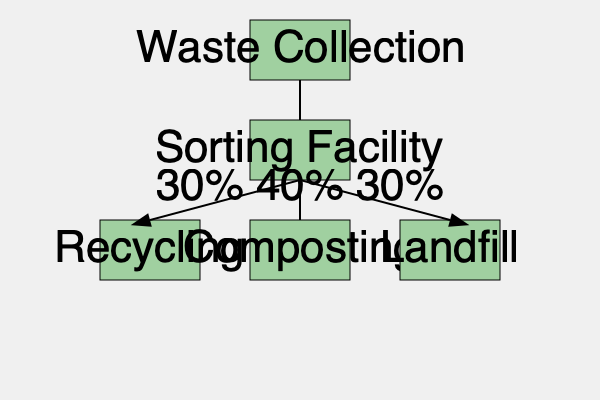Based on the flow chart of the town's waste management process, what percentage of waste is diverted from the landfill, and how could this information be used to set performance targets for the town manager? To answer this question, we need to follow these steps:

1. Analyze the flow chart:
   - Waste is first collected and then sent to a sorting facility.
   - From the sorting facility, waste is distributed to three destinations: Recycling, Composting, and Landfill.

2. Calculate the percentage diverted from the landfill:
   - Recycling receives 30% of the waste.
   - Composting receives 40% of the waste.
   - Landfill receives 30% of the waste.
   - Total diverted = Recycling + Composting = 30% + 40% = 70%

3. Consider how this information can be used for setting performance targets:
   - The current diversion rate of 70% can serve as a baseline.
   - Future targets could aim to increase this percentage, e.g., reaching 75% or 80% diversion.
   - Specific targets could be set for increasing recycling or composting rates.
   - The town manager could be tasked with implementing programs or initiatives to achieve these targets.
   - Progress could be measured annually or quarterly to assess the effectiveness of waste management strategies.

4. Potential areas for improvement:
   - Enhancing public education on proper waste sorting.
   - Expanding recycling and composting facilities.
   - Implementing incentives for waste reduction and proper disposal.
   - Exploring new technologies or partnerships to increase waste diversion.

By using this data to set clear, measurable targets, the state government official can effectively evaluate the town manager's performance in improving the town's waste management efficiency and sustainability.
Answer: 70% diverted; set targets to increase diversion rate and improve waste management strategies. 